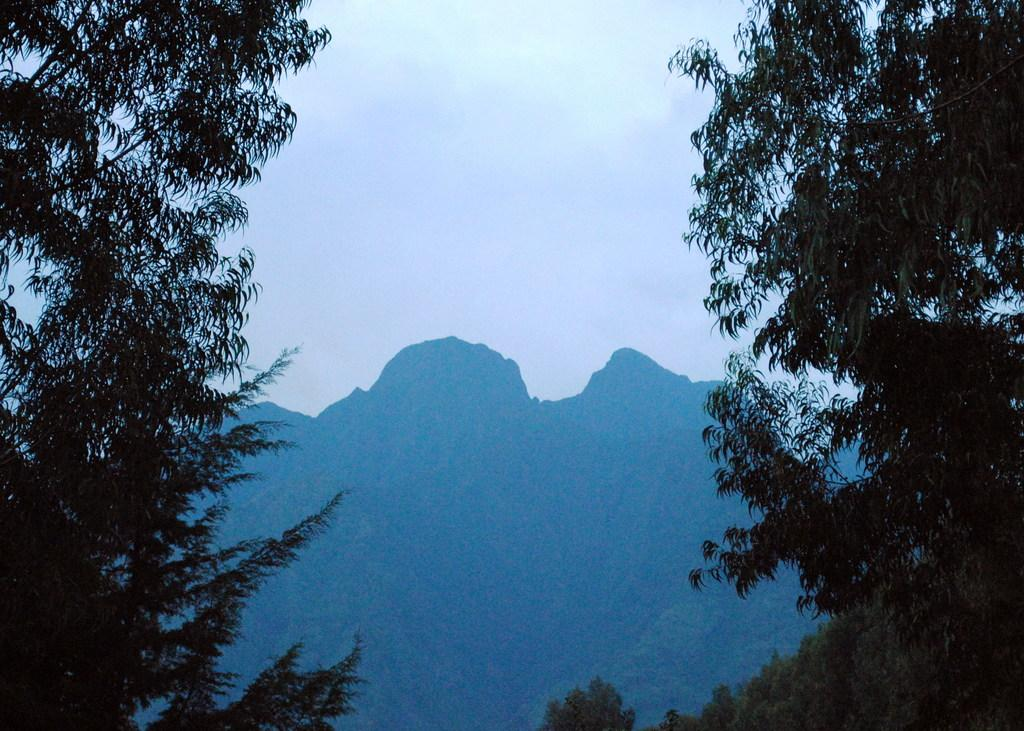What is the main subject of the picture? The main subject of the picture is a mountain. What can be seen on both sides of the mountain? There are trees on both sides of the mountain. What is the condition of the sky in the picture? The sky is clear in the picture. What type of animal can be seen hiding in the bushes near the mountain? There are no animals or bushes present in the image; it only features a mountain and trees. 